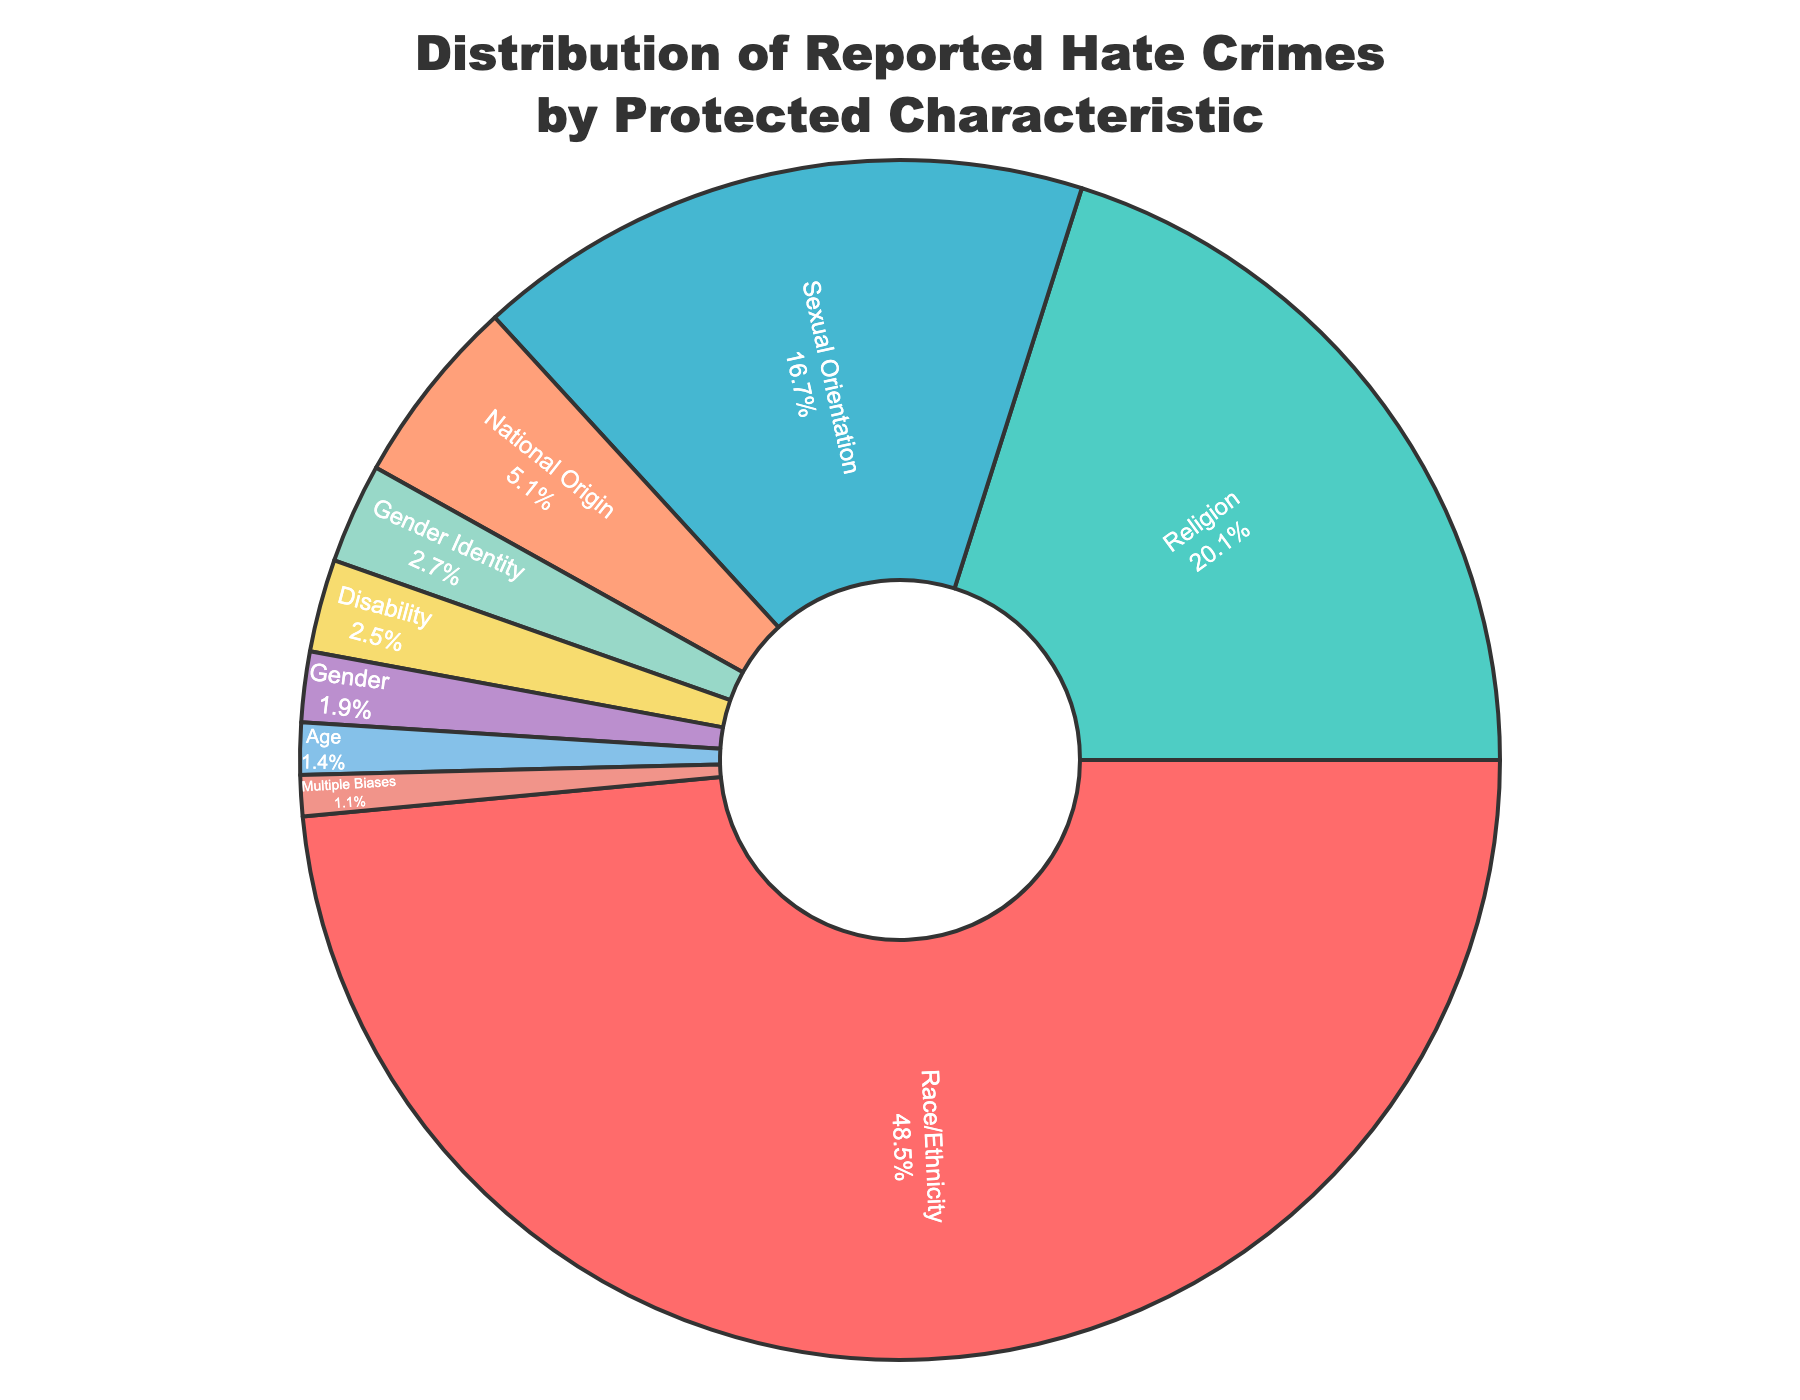What percentage of reported hate crimes are related to sexual orientation? The figure shows a slice labeled "Sexual Orientation" with a percentage value inside it. Looking at the slice, it shows 16.7%.
Answer: 16.7% Which protected characteristic has the highest percentage of reported hate crimes? By observing the sizes of the slices in the pie chart, the largest slice is labeled "Race/Ethnicity" with a percentage of 48.5%.
Answer: Race/Ethnicity What is the combined percentage of hate crimes reported for Religion and National Origin? Adding the percentages for Religion and National Origin together: 20.1% + 5.1% = 25.2%.
Answer: 25.2% How does the percentage for Disability compare to that for Gender? By comparing the slices labeled "Disability" and "Gender", Disability is 2.5% and Gender is 1.9%. Disability is greater than Gender.
Answer: Disability is greater Which protected characteristic has the smallest percentage of reported hate crimes? The smallest slice in the pie chart is labeled "Multiple Biases" with a percentage of 1.1%.
Answer: Multiple Biases What percentage of reported hate crimes concern Gender Identity? The figure shows a slice labeled "Gender Identity" with a percentage value inside it. Looking at the slice, it shows 2.7%.
Answer: 2.7% What is the total percentage of reported hate crimes for characteristics other than Race/Ethnicity? Summing all percentages except Race/Ethnicity: 20.1% + 16.7% + 2.7% + 2.5% + 1.9% + 1.4% + 5.1% + 1.1% = 51.5%.
Answer: 51.5% What is the difference in percentage between Religion and Age? Subtracting the percentage for Age from that for Religion: 20.1% - 1.4% = 18.7%.
Answer: 18.7% Are there any protected characteristics that have reported hate crimes percentages less than 2%? By observing the labeled slices, Gender (1.9%), Age (1.4%), and Multiple Biases (1.1%) all fall below 2%.
Answer: Yes, Gender, Age, and Multiple Biases 